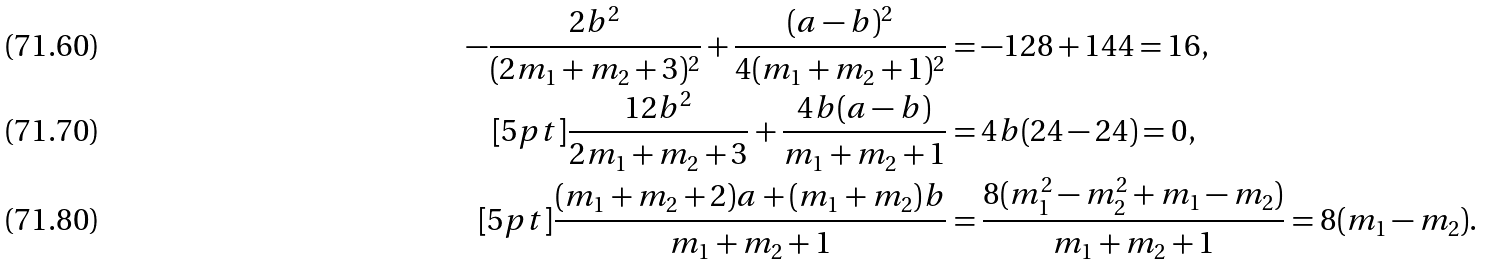<formula> <loc_0><loc_0><loc_500><loc_500>- \frac { 2 b ^ { 2 } } { ( 2 m _ { 1 } + m _ { 2 } + 3 ) ^ { 2 } } + \frac { ( a - b ) ^ { 2 } } { 4 ( m _ { 1 } + m _ { 2 } + 1 ) ^ { 2 } } & = - 1 2 8 + 1 4 4 = 1 6 , \\ [ 5 p t ] \frac { 1 2 b ^ { 2 } } { 2 m _ { 1 } + m _ { 2 } + 3 } + \frac { 4 b ( a - b ) } { m _ { 1 } + m _ { 2 } + 1 } & = 4 b ( 2 4 - 2 4 ) = 0 , \\ [ 5 p t ] \frac { ( m _ { 1 } + m _ { 2 } + 2 ) a + ( m _ { 1 } + m _ { 2 } ) b } { m _ { 1 } + m _ { 2 } + 1 } & = \frac { 8 ( m _ { 1 } ^ { 2 } - m _ { 2 } ^ { 2 } + m _ { 1 } - m _ { 2 } ) } { m _ { 1 } + m _ { 2 } + 1 } = 8 ( m _ { 1 } - m _ { 2 } ) .</formula> 